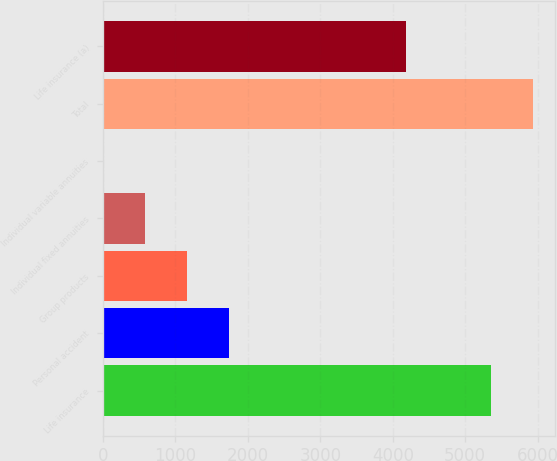<chart> <loc_0><loc_0><loc_500><loc_500><bar_chart><fcel>Life insurance<fcel>Personal accident<fcel>Group products<fcel>Individual fixed annuities<fcel>Individual variable annuities<fcel>Total<fcel>Life insurance (a)<nl><fcel>5360<fcel>1734<fcel>1158<fcel>582<fcel>6<fcel>5936<fcel>4188<nl></chart> 